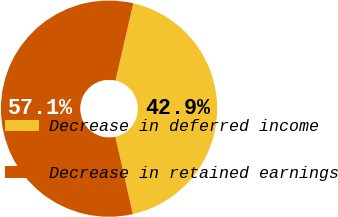<chart> <loc_0><loc_0><loc_500><loc_500><pie_chart><fcel>Decrease in deferred income<fcel>Decrease in retained earnings<nl><fcel>42.86%<fcel>57.14%<nl></chart> 